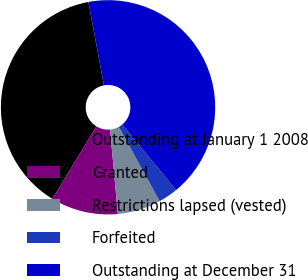<chart> <loc_0><loc_0><loc_500><loc_500><pie_chart><fcel>Outstanding at January 1 2008<fcel>Granted<fcel>Restrictions lapsed (vested)<fcel>Forfeited<fcel>Outstanding at December 31<nl><fcel>38.38%<fcel>10.14%<fcel>6.54%<fcel>2.95%<fcel>41.98%<nl></chart> 